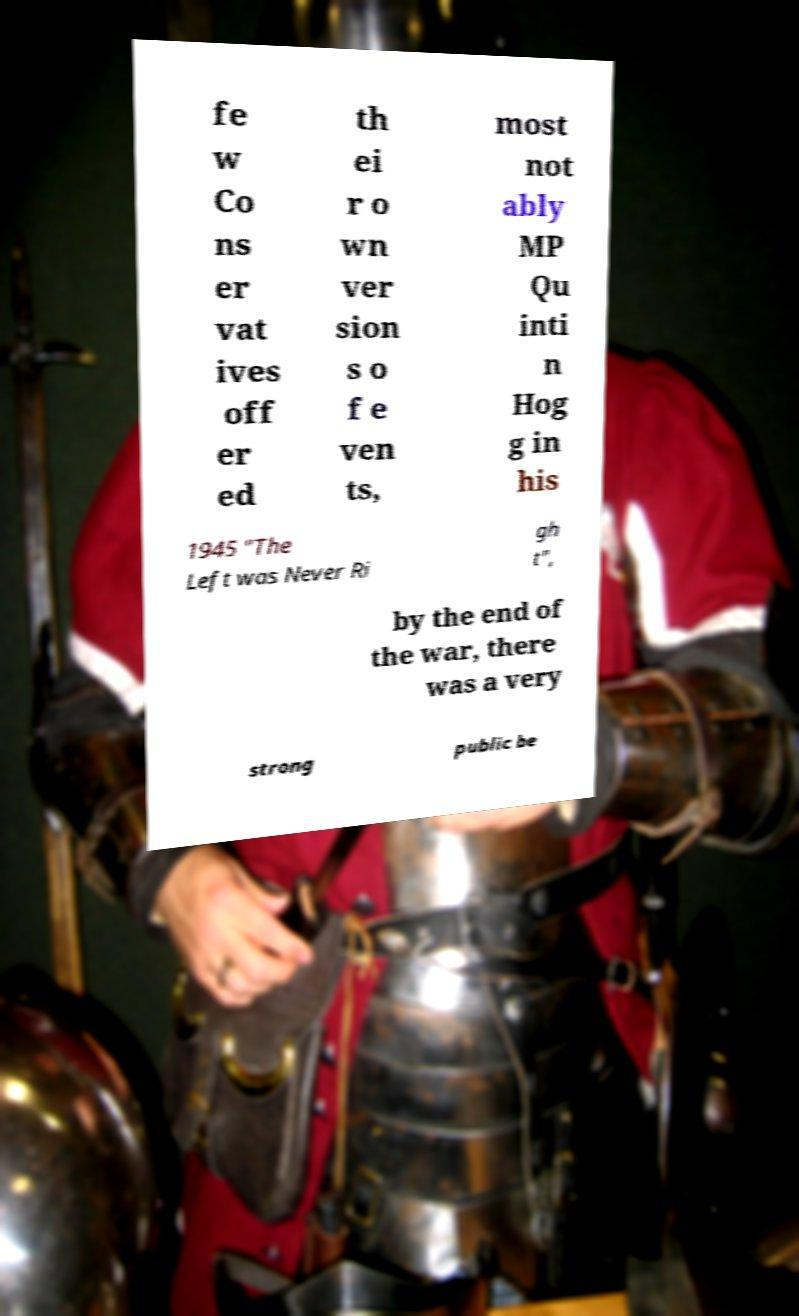What messages or text are displayed in this image? I need them in a readable, typed format. fe w Co ns er vat ives off er ed th ei r o wn ver sion s o f e ven ts, most not ably MP Qu inti n Hog g in his 1945 "The Left was Never Ri gh t", by the end of the war, there was a very strong public be 